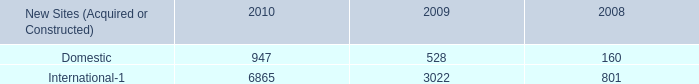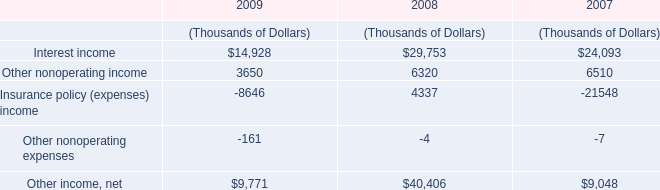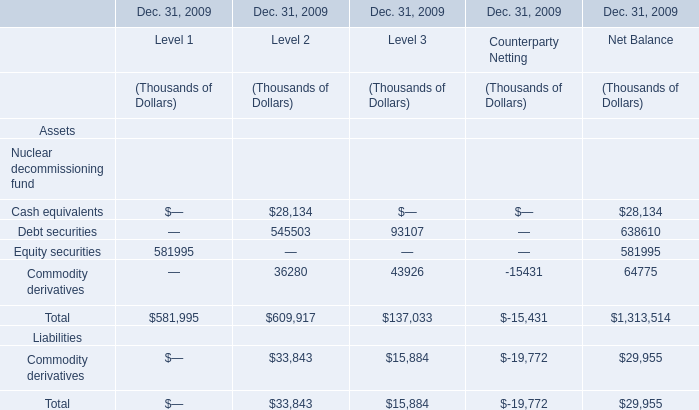What was the average of the Total in the section where Total is positive? (in thousand) 
Computations: (((581995 + 609917) + 137033) / 3)
Answer: 442981.66667. 